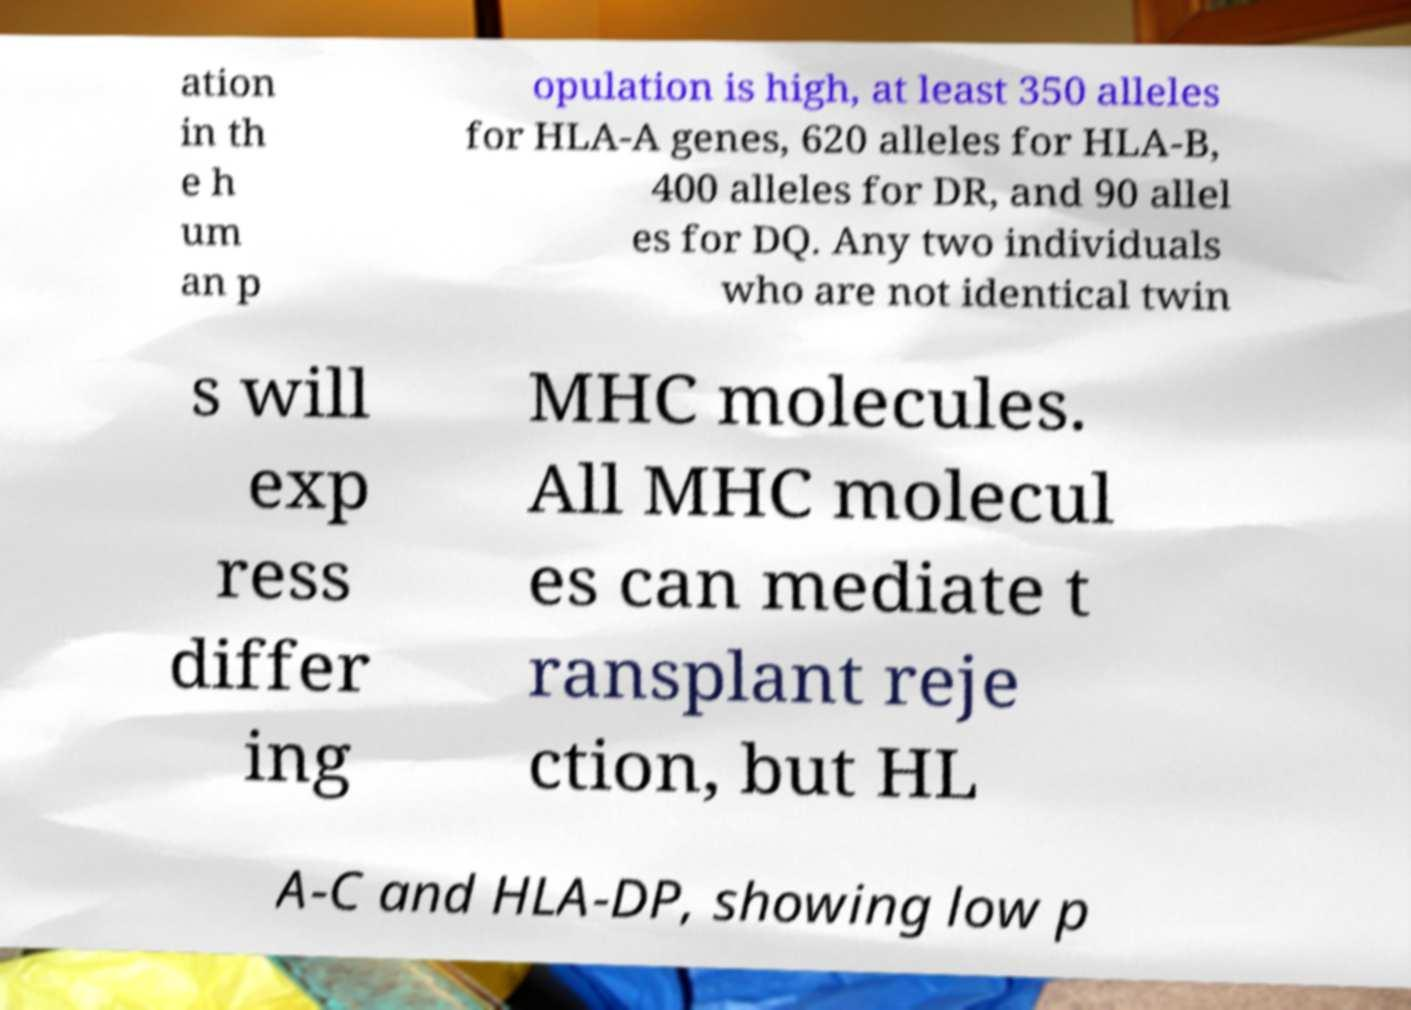Could you extract and type out the text from this image? ation in th e h um an p opulation is high, at least 350 alleles for HLA-A genes, 620 alleles for HLA-B, 400 alleles for DR, and 90 allel es for DQ. Any two individuals who are not identical twin s will exp ress differ ing MHC molecules. All MHC molecul es can mediate t ransplant reje ction, but HL A-C and HLA-DP, showing low p 